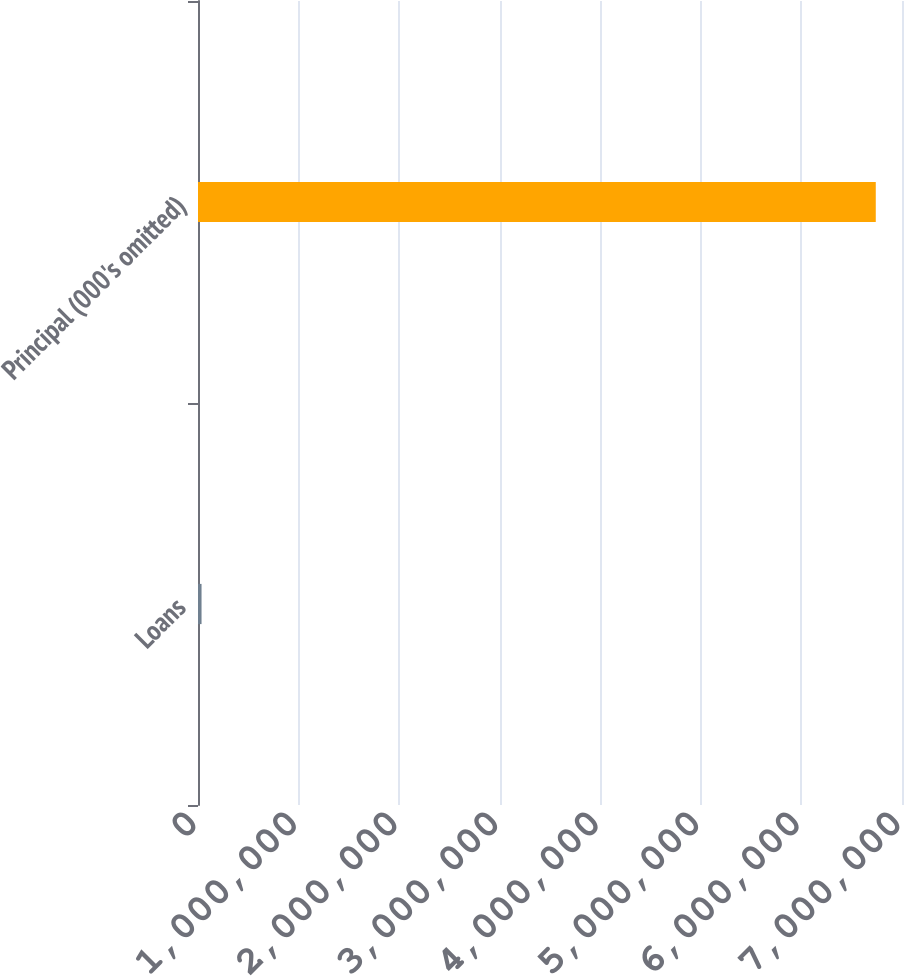Convert chart to OTSL. <chart><loc_0><loc_0><loc_500><loc_500><bar_chart><fcel>Loans<fcel>Principal (000's omitted)<nl><fcel>35232<fcel>6.7392e+06<nl></chart> 